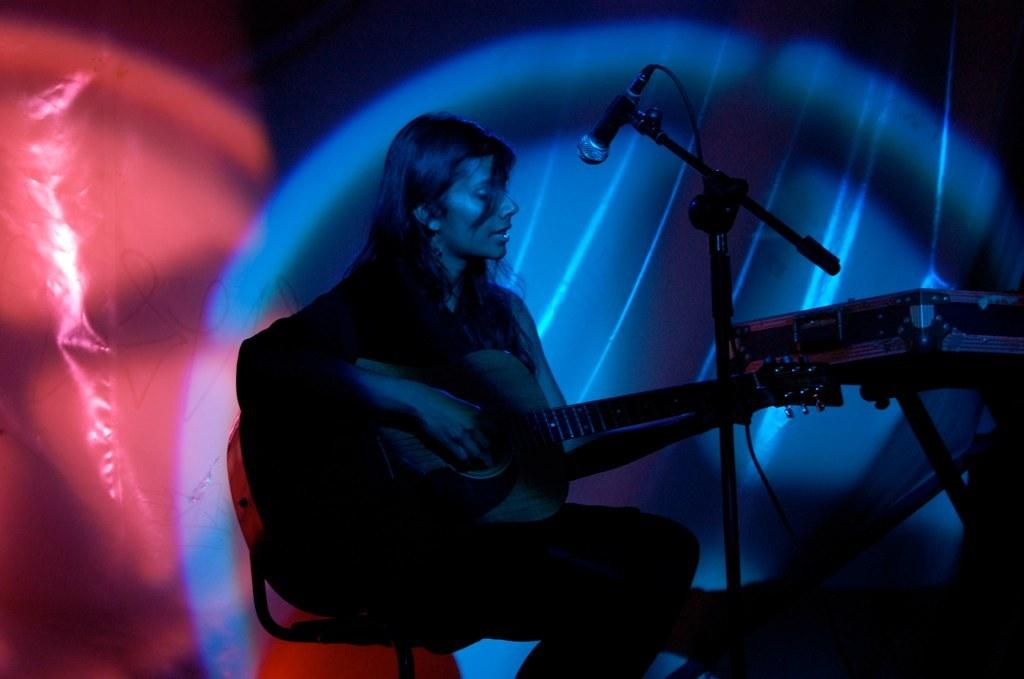Who is the main subject in the image? There is a woman in the image. What is the woman doing in the image? The woman is sitting on a chair and holding a guitar in her hand. What other objects are present in the image? There is a microphone with a stand, and there is a box on the stand. What type of vein is visible on the woman's hand in the image? There are no visible veins on the woman's hand in the image. What type of root can be seen growing from the guitar in the image? There are no roots visible in the image, and the guitar is not a plant. 